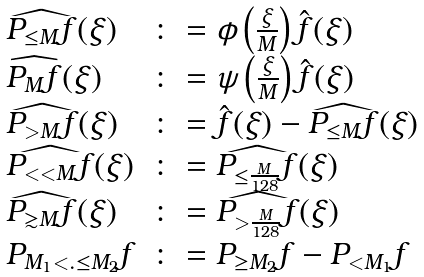Convert formula to latex. <formula><loc_0><loc_0><loc_500><loc_500>\begin{array} { l l } \widehat { P _ { \leq M } f } ( \xi ) & \colon = \phi \left ( \frac { \xi } { M } \right ) \hat { f } ( \xi ) \\ \widehat { P _ { M } f } ( \xi ) & \colon = \psi \left ( \frac { \xi } { M } \right ) \hat { f } ( \xi ) \\ \widehat { P _ { > M } f } ( \xi ) & \colon = \hat { f } ( \xi ) - \widehat { P _ { \leq M } f } ( \xi ) \\ \widehat { P _ { < < M } f } ( \xi ) & \colon = \widehat { P _ { \leq \frac { M } { 1 2 8 } } f } ( \xi ) \\ \widehat { P _ { \gtrsim M } f } ( \xi ) & \colon = \widehat { P _ { > \frac { M } { 1 2 8 } } f } ( \xi ) \\ P _ { M _ { 1 } < . \leq M _ { 2 } } f & \colon = P _ { \geq M _ { 2 } } f - P _ { < M _ { 1 } } f \\ \end{array}</formula> 